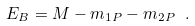Convert formula to latex. <formula><loc_0><loc_0><loc_500><loc_500>E _ { B } = M - m _ { 1 P } - m _ { 2 P } \ .</formula> 